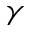<formula> <loc_0><loc_0><loc_500><loc_500>\gamma</formula> 